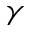<formula> <loc_0><loc_0><loc_500><loc_500>\gamma</formula> 